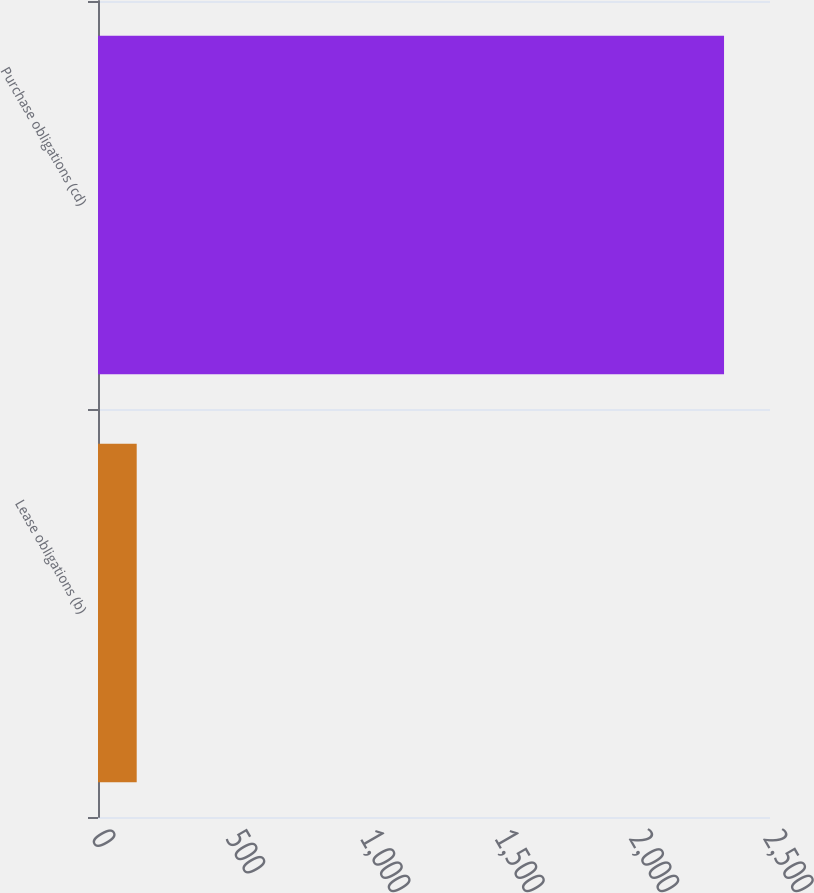Convert chart to OTSL. <chart><loc_0><loc_0><loc_500><loc_500><bar_chart><fcel>Lease obligations (b)<fcel>Purchase obligations (cd)<nl><fcel>144<fcel>2329<nl></chart> 